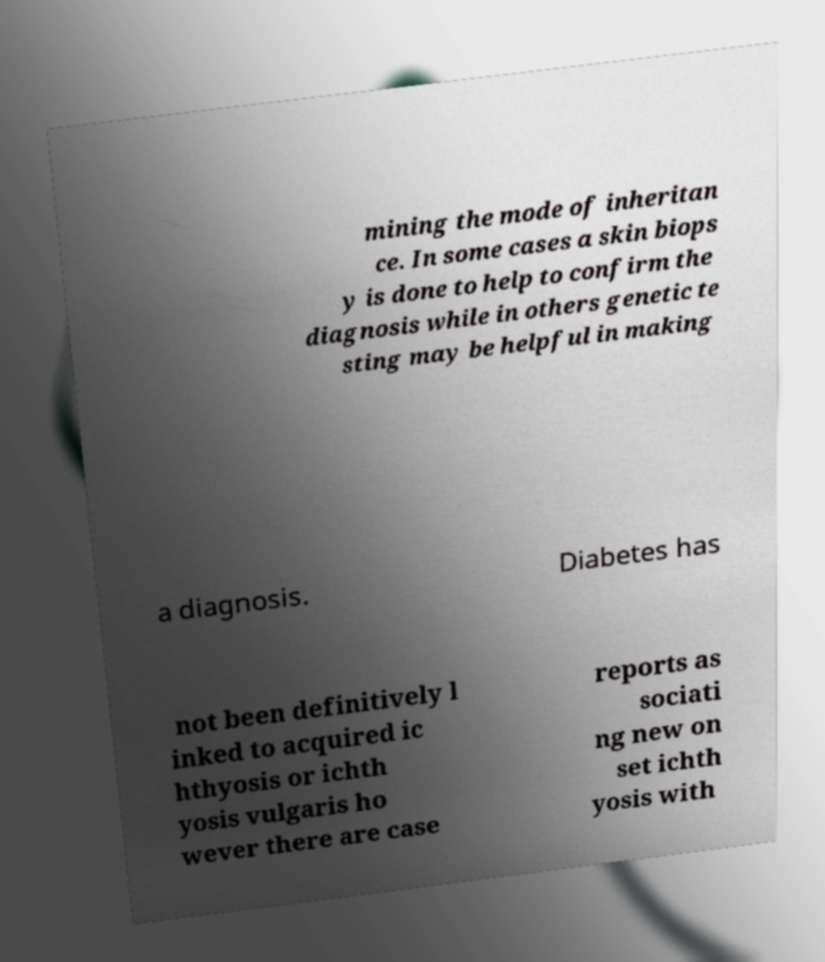Can you accurately transcribe the text from the provided image for me? mining the mode of inheritan ce. In some cases a skin biops y is done to help to confirm the diagnosis while in others genetic te sting may be helpful in making a diagnosis. Diabetes has not been definitively l inked to acquired ic hthyosis or ichth yosis vulgaris ho wever there are case reports as sociati ng new on set ichth yosis with 